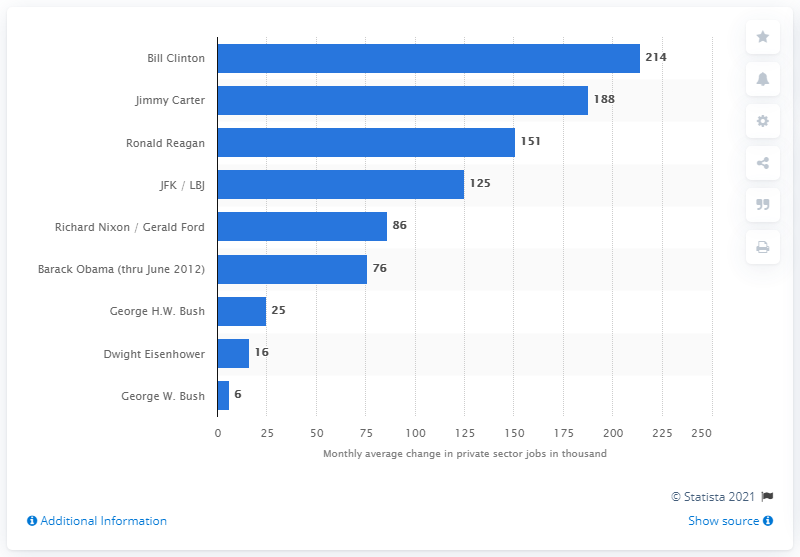Give some essential details in this illustration. In the post-war era, Bill Clinton served as the President of the United States. 